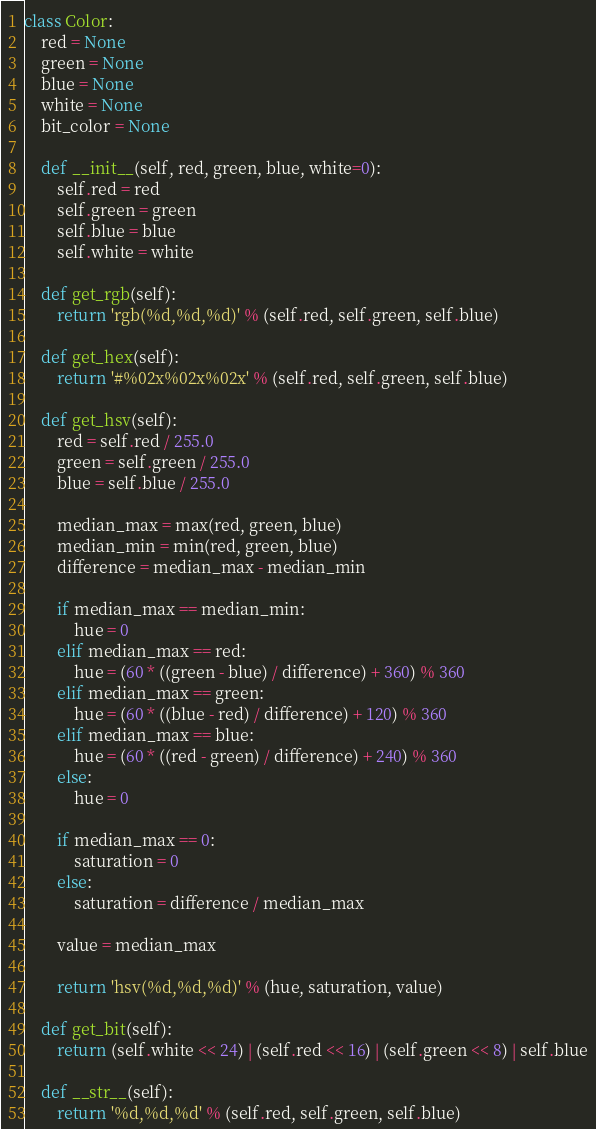<code> <loc_0><loc_0><loc_500><loc_500><_Python_>

class Color:
    red = None
    green = None
    blue = None
    white = None
    bit_color = None

    def __init__(self, red, green, blue, white=0):
        self.red = red
        self.green = green
        self.blue = blue
        self.white = white

    def get_rgb(self):
        return 'rgb(%d,%d,%d)' % (self.red, self.green, self.blue)

    def get_hex(self):
        return '#%02x%02x%02x' % (self.red, self.green, self.blue)

    def get_hsv(self):
        red = self.red / 255.0
        green = self.green / 255.0
        blue = self.blue / 255.0

        median_max = max(red, green, blue)
        median_min = min(red, green, blue)
        difference = median_max - median_min

        if median_max == median_min:
            hue = 0
        elif median_max == red:
            hue = (60 * ((green - blue) / difference) + 360) % 360
        elif median_max == green:
            hue = (60 * ((blue - red) / difference) + 120) % 360
        elif median_max == blue:
            hue = (60 * ((red - green) / difference) + 240) % 360
        else:
            hue = 0

        if median_max == 0:
            saturation = 0
        else:
            saturation = difference / median_max

        value = median_max

        return 'hsv(%d,%d,%d)' % (hue, saturation, value)

    def get_bit(self):
        return (self.white << 24) | (self.red << 16) | (self.green << 8) | self.blue

    def __str__(self):
        return '%d,%d,%d' % (self.red, self.green, self.blue)
</code> 